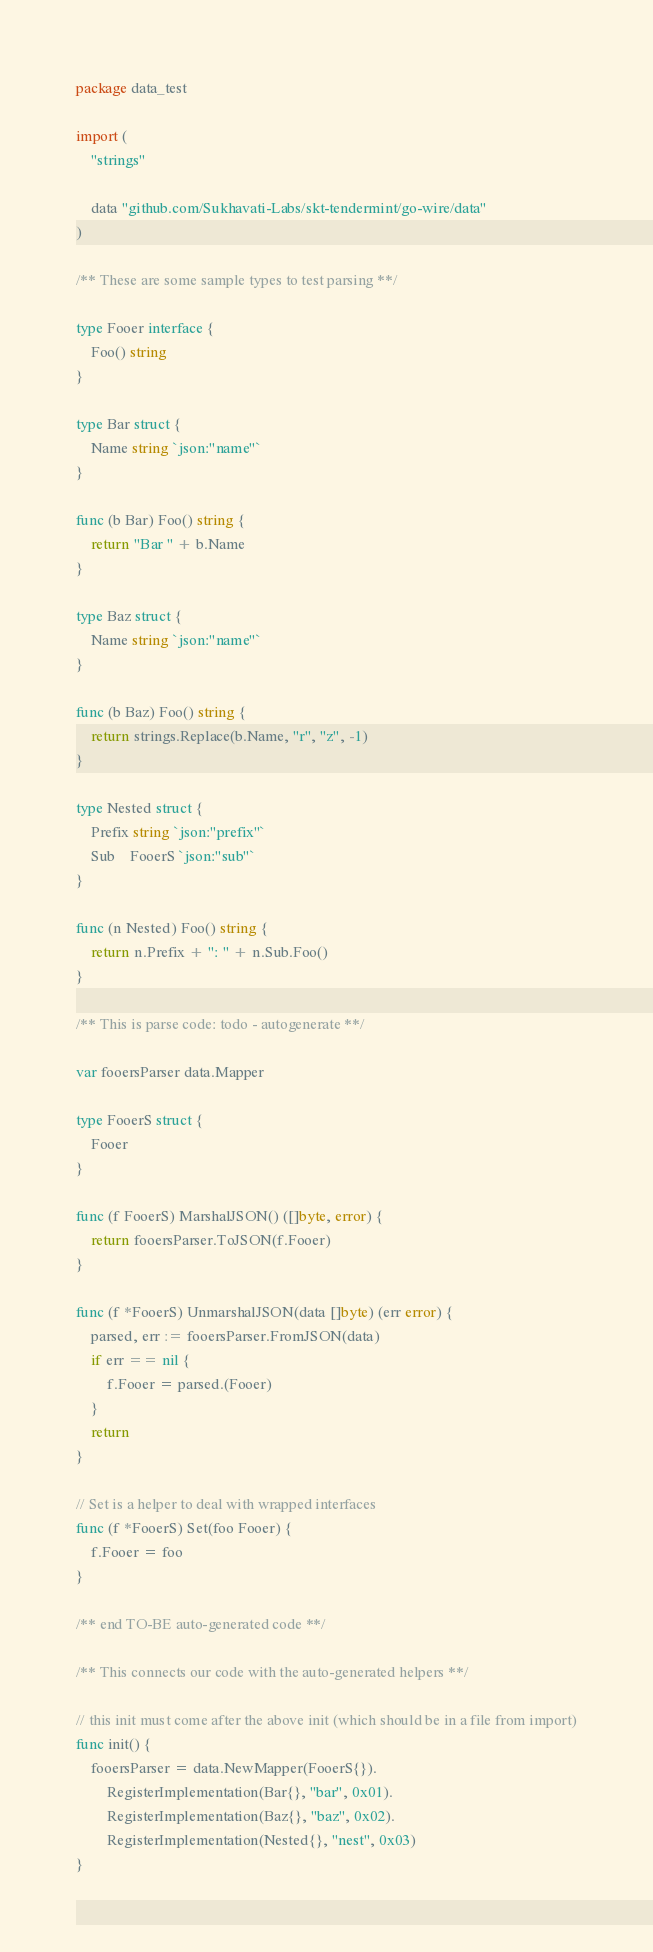<code> <loc_0><loc_0><loc_500><loc_500><_Go_>package data_test

import (
	"strings"

	data "github.com/Sukhavati-Labs/skt-tendermint/go-wire/data"
)

/** These are some sample types to test parsing **/

type Fooer interface {
	Foo() string
}

type Bar struct {
	Name string `json:"name"`
}

func (b Bar) Foo() string {
	return "Bar " + b.Name
}

type Baz struct {
	Name string `json:"name"`
}

func (b Baz) Foo() string {
	return strings.Replace(b.Name, "r", "z", -1)
}

type Nested struct {
	Prefix string `json:"prefix"`
	Sub    FooerS `json:"sub"`
}

func (n Nested) Foo() string {
	return n.Prefix + ": " + n.Sub.Foo()
}

/** This is parse code: todo - autogenerate **/

var fooersParser data.Mapper

type FooerS struct {
	Fooer
}

func (f FooerS) MarshalJSON() ([]byte, error) {
	return fooersParser.ToJSON(f.Fooer)
}

func (f *FooerS) UnmarshalJSON(data []byte) (err error) {
	parsed, err := fooersParser.FromJSON(data)
	if err == nil {
		f.Fooer = parsed.(Fooer)
	}
	return
}

// Set is a helper to deal with wrapped interfaces
func (f *FooerS) Set(foo Fooer) {
	f.Fooer = foo
}

/** end TO-BE auto-generated code **/

/** This connects our code with the auto-generated helpers **/

// this init must come after the above init (which should be in a file from import)
func init() {
	fooersParser = data.NewMapper(FooerS{}).
		RegisterImplementation(Bar{}, "bar", 0x01).
		RegisterImplementation(Baz{}, "baz", 0x02).
		RegisterImplementation(Nested{}, "nest", 0x03)
}
</code> 